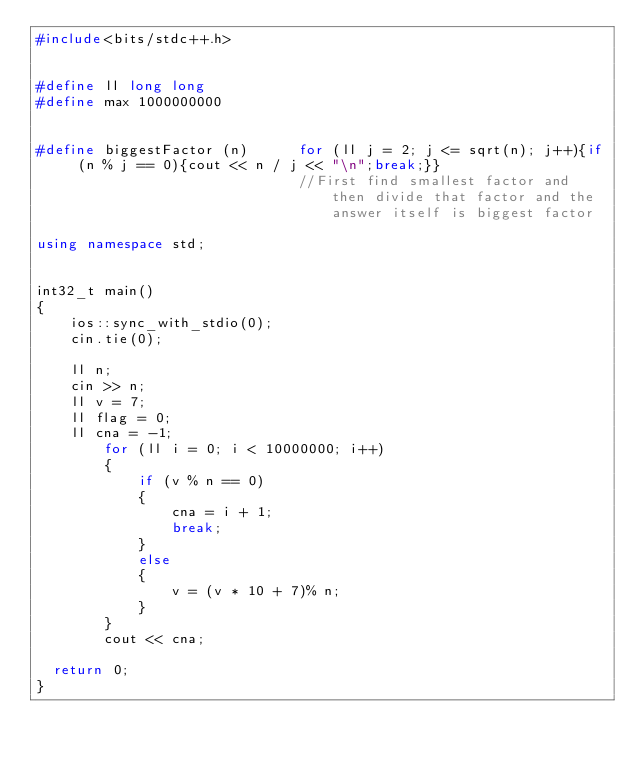Convert code to text. <code><loc_0><loc_0><loc_500><loc_500><_C++_>#include<bits/stdc++.h>
 
 
#define ll long long
#define max 1000000000
 
 
#define biggestFactor (n)      for (ll j = 2; j <= sqrt(n); j++){if (n % j == 0){cout << n / j << "\n";break;}}
                               //First find smallest factor and then divide that factor and the answer itself is biggest factor
                          
using namespace std;

 
int32_t main()
{
    ios::sync_with_stdio(0);
    cin.tie(0);

    ll n;
    cin >> n;
    ll v = 7;
    ll flag = 0;
    ll cna = -1;
        for (ll i = 0; i < 10000000; i++)
        {
            if (v % n == 0)
            {
                cna = i + 1;
                break;
            }
            else
            {
                v = (v * 10 + 7)% n;
            }
        }
        cout << cna;
    
	return 0;
}</code> 